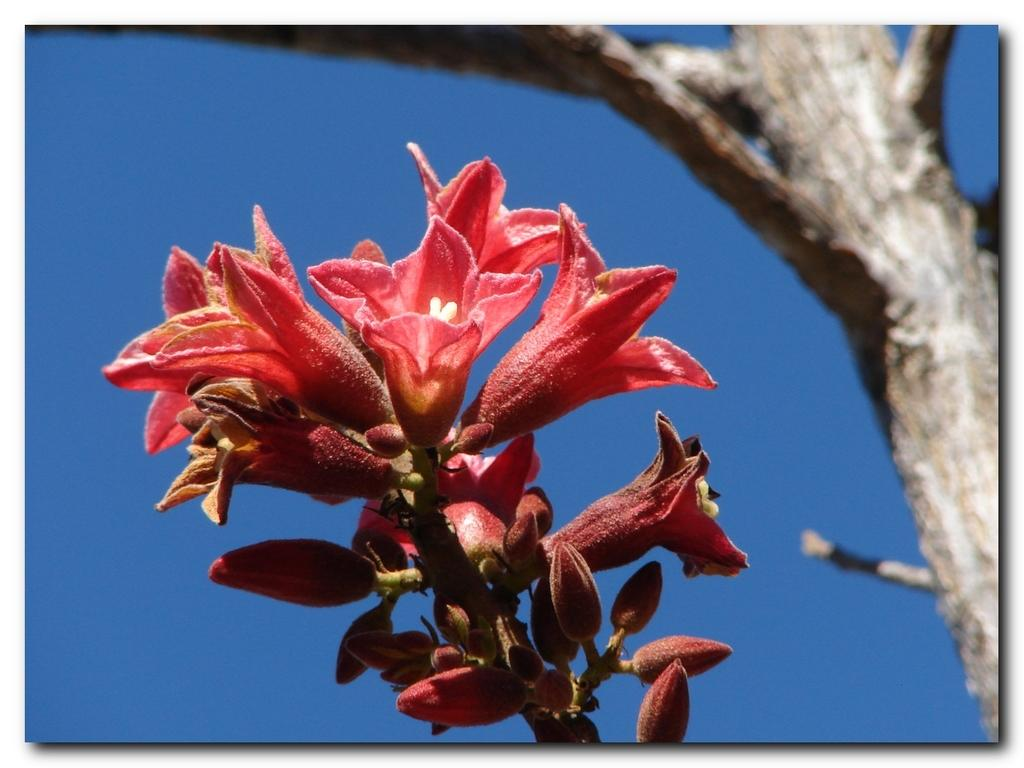What type of flowers can be seen in the image? There are red color flowers in the image. Are there any flowers that are not fully bloomed in the image? Yes, there are flower buds in the image. What part of a tree is visible in the image? There is a tree trunk visible in the image. What color is the background of the image? The background of the image is blue. What team is playing in the background of the image? There is no team playing in the image; it features flowers, flower buds, a tree trunk, and a blue background. Can you see a beetle crawling on the tree trunk in the image? There is no beetle present in the image; it only features flowers, flower buds, a tree trunk, and a blue background. 